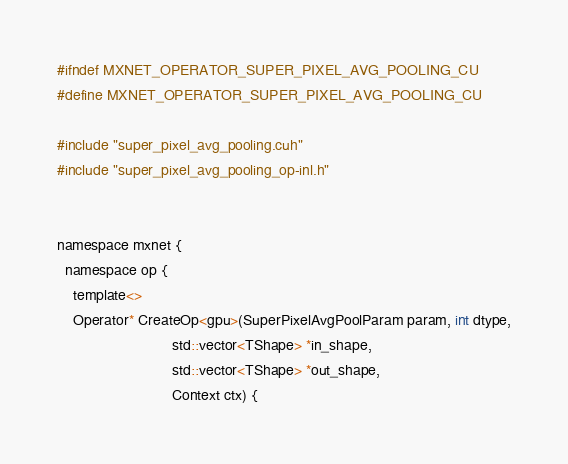Convert code to text. <code><loc_0><loc_0><loc_500><loc_500><_Cuda_>#ifndef MXNET_OPERATOR_SUPER_PIXEL_AVG_POOLING_CU
#define MXNET_OPERATOR_SUPER_PIXEL_AVG_POOLING_CU

#include "super_pixel_avg_pooling.cuh"
#include "super_pixel_avg_pooling_op-inl.h"


namespace mxnet {
  namespace op {
    template<>
    Operator* CreateOp<gpu>(SuperPixelAvgPoolParam param, int dtype,
                            std::vector<TShape> *in_shape,
                            std::vector<TShape> *out_shape,
                            Context ctx) {</code> 